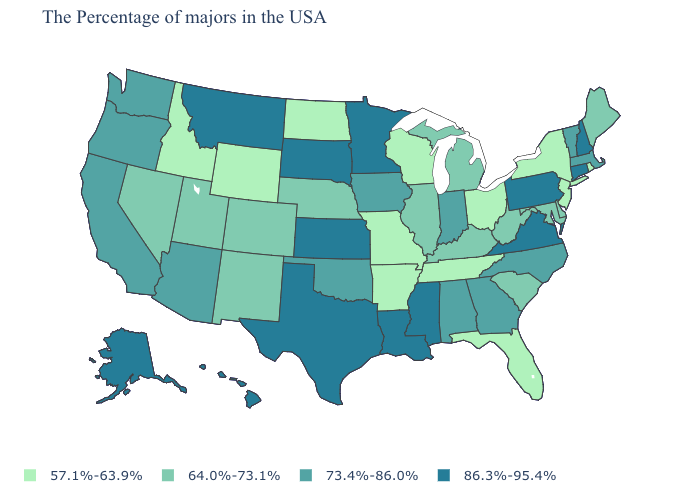Does the map have missing data?
Quick response, please. No. Which states have the lowest value in the USA?
Answer briefly. Rhode Island, New York, New Jersey, Ohio, Florida, Tennessee, Wisconsin, Missouri, Arkansas, North Dakota, Wyoming, Idaho. Does South Dakota have the lowest value in the USA?
Write a very short answer. No. What is the value of Missouri?
Quick response, please. 57.1%-63.9%. Name the states that have a value in the range 64.0%-73.1%?
Concise answer only. Maine, Delaware, Maryland, South Carolina, West Virginia, Michigan, Kentucky, Illinois, Nebraska, Colorado, New Mexico, Utah, Nevada. Name the states that have a value in the range 64.0%-73.1%?
Short answer required. Maine, Delaware, Maryland, South Carolina, West Virginia, Michigan, Kentucky, Illinois, Nebraska, Colorado, New Mexico, Utah, Nevada. What is the highest value in the West ?
Write a very short answer. 86.3%-95.4%. Name the states that have a value in the range 64.0%-73.1%?
Quick response, please. Maine, Delaware, Maryland, South Carolina, West Virginia, Michigan, Kentucky, Illinois, Nebraska, Colorado, New Mexico, Utah, Nevada. Name the states that have a value in the range 64.0%-73.1%?
Short answer required. Maine, Delaware, Maryland, South Carolina, West Virginia, Michigan, Kentucky, Illinois, Nebraska, Colorado, New Mexico, Utah, Nevada. Which states have the lowest value in the MidWest?
Answer briefly. Ohio, Wisconsin, Missouri, North Dakota. Does Nevada have the same value as Illinois?
Write a very short answer. Yes. What is the lowest value in the USA?
Keep it brief. 57.1%-63.9%. Does Utah have the highest value in the USA?
Write a very short answer. No. What is the value of California?
Answer briefly. 73.4%-86.0%. Name the states that have a value in the range 64.0%-73.1%?
Write a very short answer. Maine, Delaware, Maryland, South Carolina, West Virginia, Michigan, Kentucky, Illinois, Nebraska, Colorado, New Mexico, Utah, Nevada. 